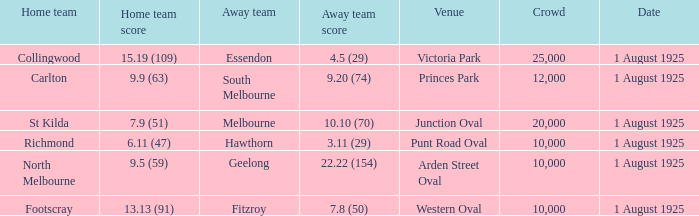What was the away team's score during the match held at the western oval? 7.8 (50). 